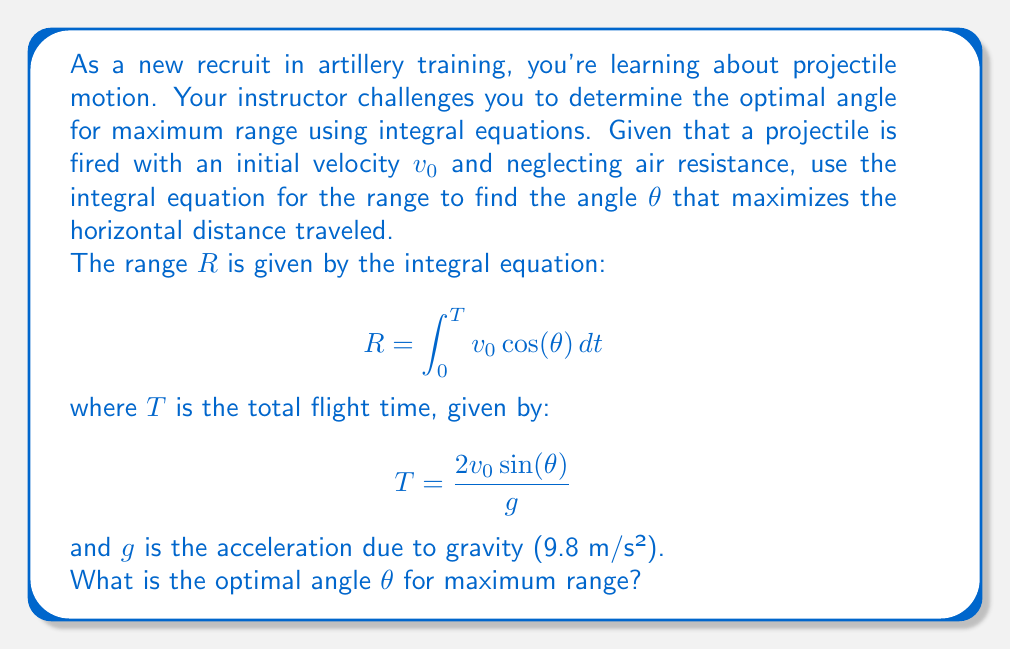Could you help me with this problem? Let's approach this step-by-step:

1) First, we need to evaluate the integral for R:

   $$ R = \int_0^T v_0 \cos(\theta) dt = v_0 \cos(\theta) \int_0^T dt = v_0 \cos(\theta) T $$

2) Now, substitute the expression for T:

   $$ R = v_0 \cos(\theta) \cdot \frac{2v_0 \sin(\theta)}{g} = \frac{2v_0^2 \sin(\theta) \cos(\theta)}{g} $$

3) Recall the trigonometric identity: $2\sin(\theta)\cos(\theta) = \sin(2\theta)$

   $$ R = \frac{v_0^2 \sin(2\theta)}{g} $$

4) To find the maximum range, we need to find the value of θ that maximizes this function. We can do this by taking the derivative with respect to θ and setting it to zero:

   $$ \frac{dR}{d\theta} = \frac{v_0^2}{g} \cdot 2\cos(2\theta) = 0 $$

5) Solving this equation:

   $$ 2\cos(2\theta) = 0 $$
   $$ \cos(2\theta) = 0 $$

6) The cosine function is zero when its argument is π/2 or 3π/2. Since we're dealing with a physical angle, we're interested in the positive solution:

   $$ 2\theta = \frac{\pi}{2} $$
   $$ \theta = \frac{\pi}{4} = 45° $$

Therefore, the optimal angle for maximum range is 45°.
Answer: 45° 